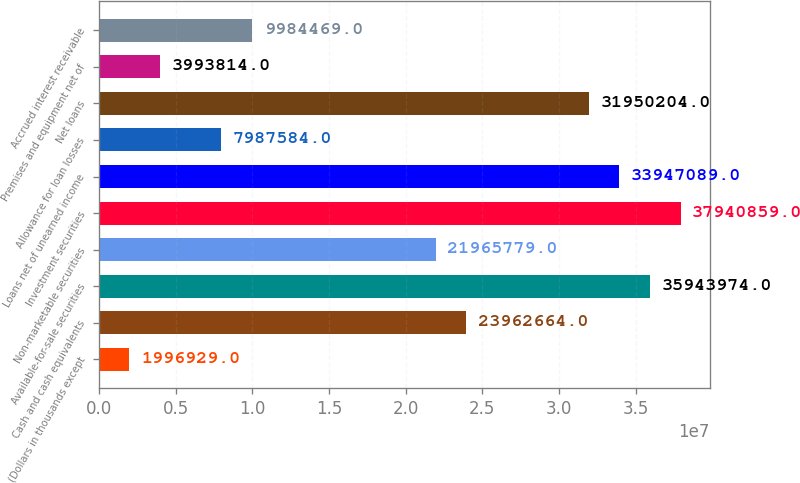Convert chart to OTSL. <chart><loc_0><loc_0><loc_500><loc_500><bar_chart><fcel>(Dollars in thousands except<fcel>Cash and cash equivalents<fcel>Available-for-sale securities<fcel>Non-marketable securities<fcel>Investment securities<fcel>Loans net of unearned income<fcel>Allowance for loan losses<fcel>Net loans<fcel>Premises and equipment net of<fcel>Accrued interest receivable<nl><fcel>1.99693e+06<fcel>2.39627e+07<fcel>3.5944e+07<fcel>2.19658e+07<fcel>3.79409e+07<fcel>3.39471e+07<fcel>7.98758e+06<fcel>3.19502e+07<fcel>3.99381e+06<fcel>9.98447e+06<nl></chart> 